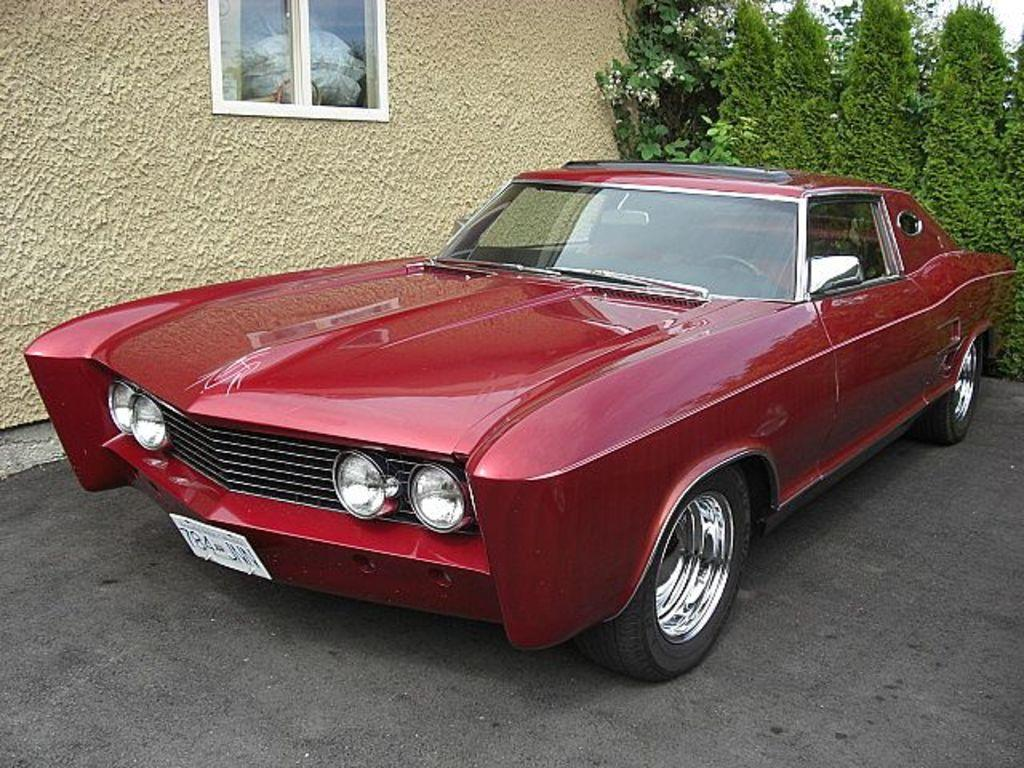What is the main subject of the image? There is a car in the image. Where is the car located in relation to other objects? The car is in front of a wall. What can be seen at the top of the image? There is a window at the top of the image. What type of vegetation is visible in the image? There are trees in the top right of the image. What type of war is being depicted in the image? There is no depiction of war in the image; it features a car in front of a wall with a window and trees visible. How many examples of cent can be seen in the image? There are no examples of cent present in the image. 